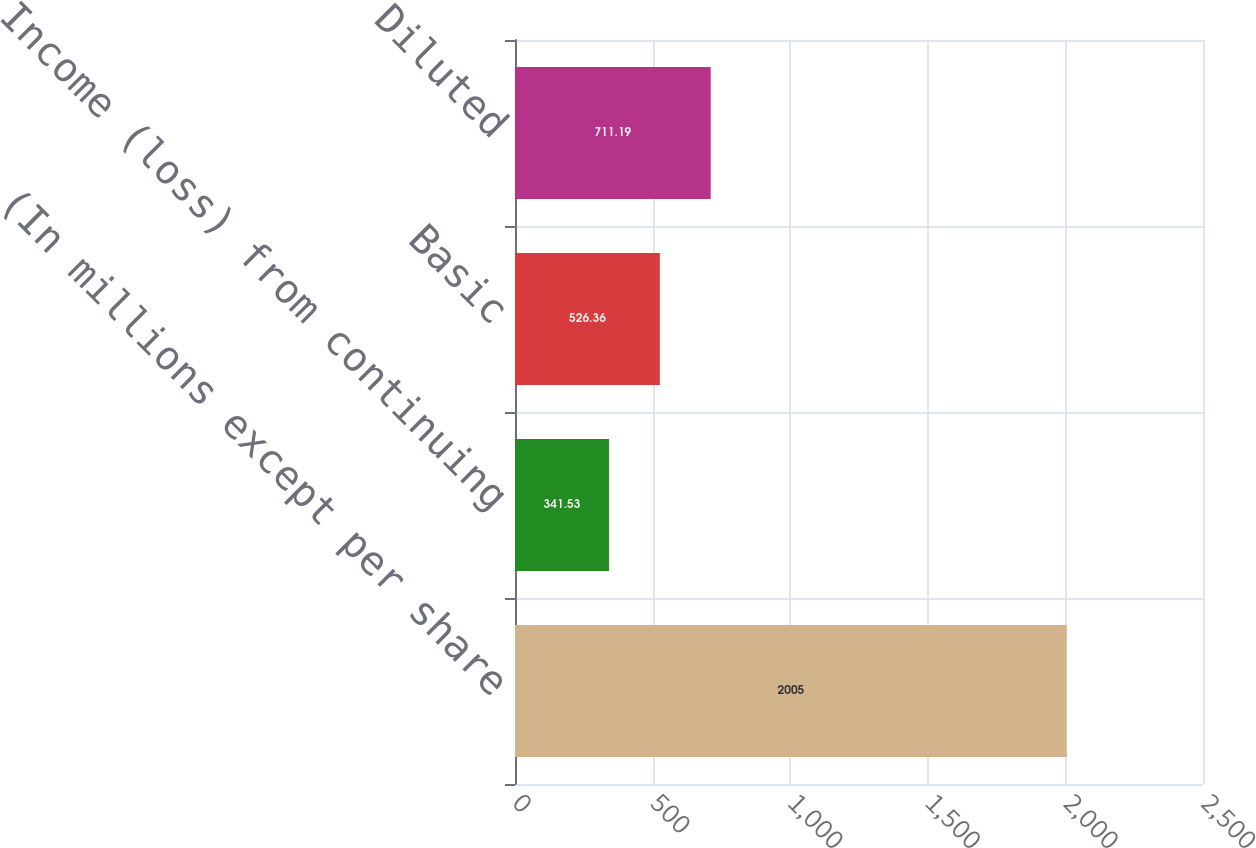Convert chart to OTSL. <chart><loc_0><loc_0><loc_500><loc_500><bar_chart><fcel>(In millions except per share<fcel>Income (loss) from continuing<fcel>Basic<fcel>Diluted<nl><fcel>2005<fcel>341.53<fcel>526.36<fcel>711.19<nl></chart> 